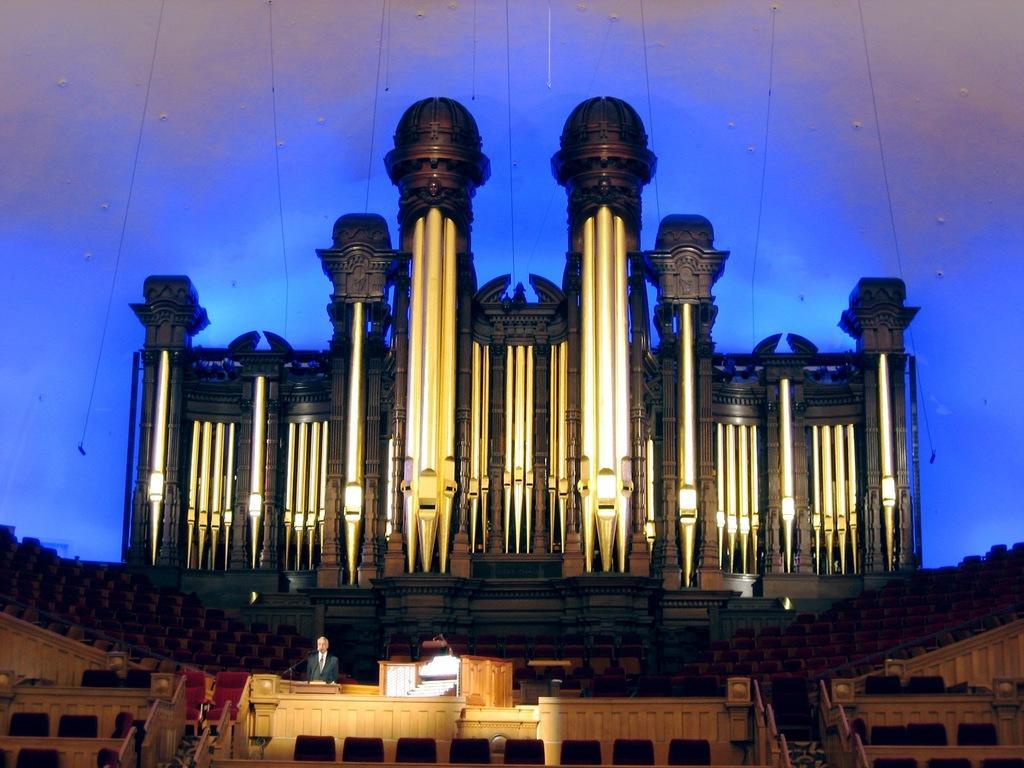Please provide a concise description of this image. In this picture I can see there is a man standing here at the wooden frame and there is a wooden frame. In the backdrop there are many empty chairs and there is a wall in the backdrop. 